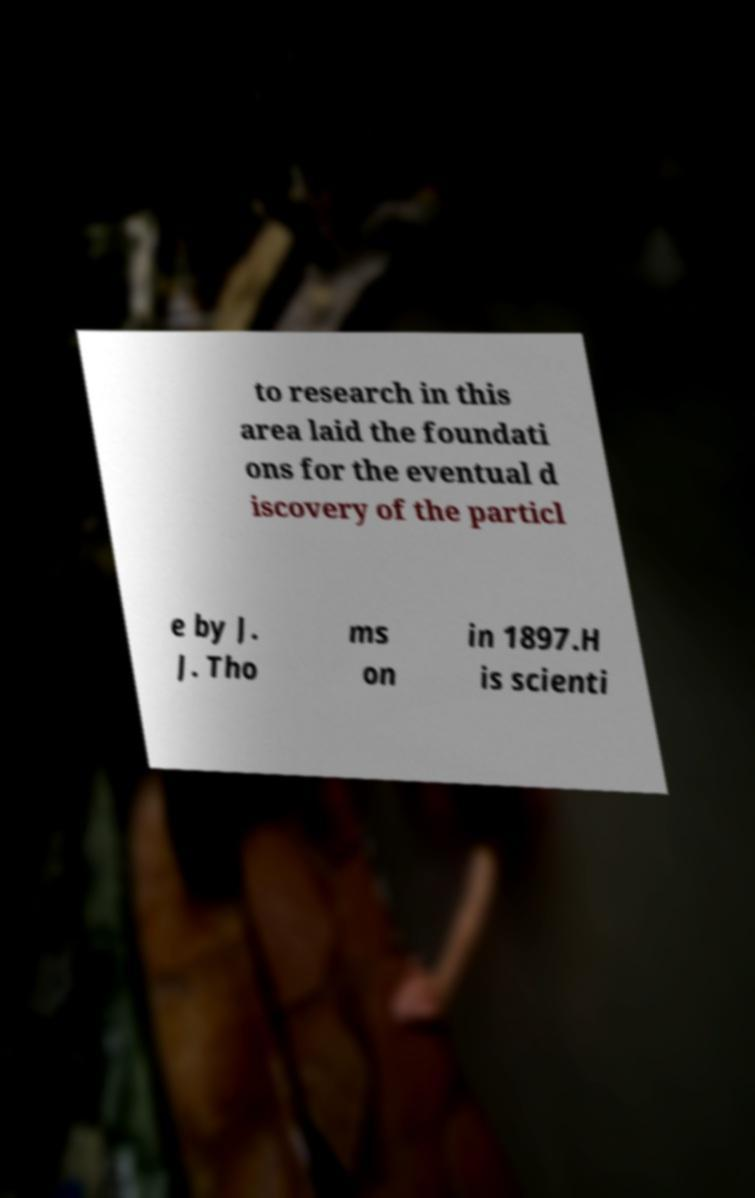Please identify and transcribe the text found in this image. to research in this area laid the foundati ons for the eventual d iscovery of the particl e by J. J. Tho ms on in 1897.H is scienti 